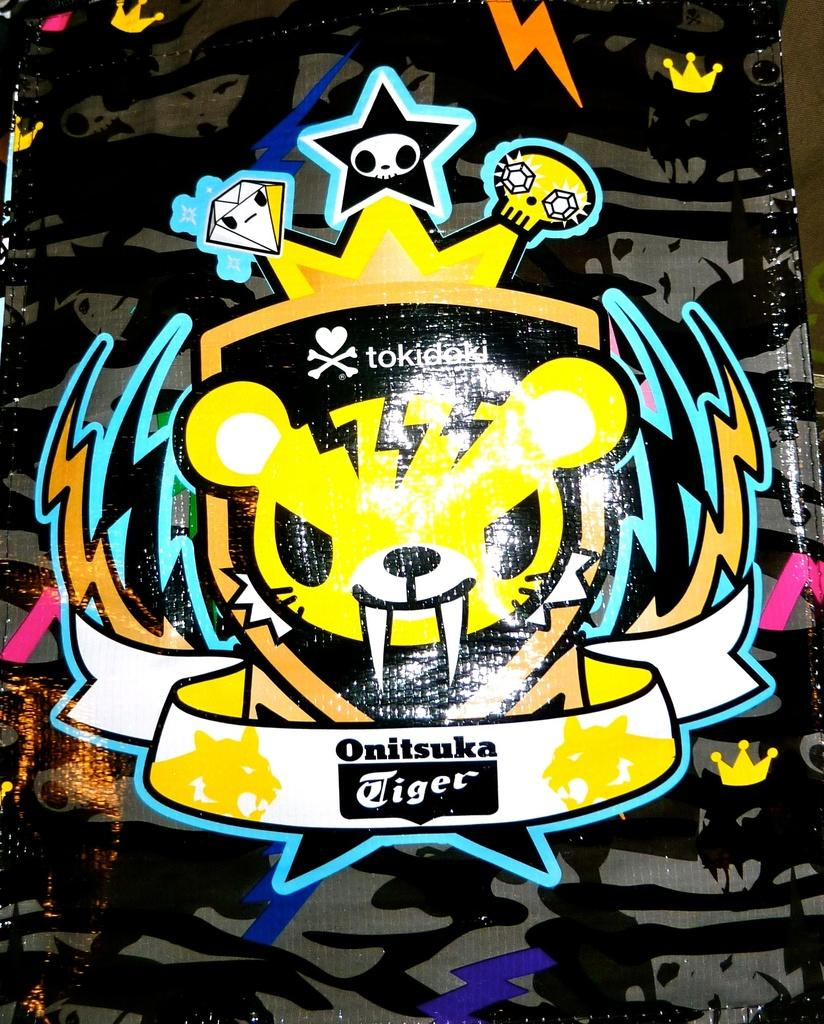What is the main subject of the image? The main subject of the image is a logo cover. Can you describe the location of the logo cover in the image? The logo cover is in the middle of the image. What is the name of the person holding the meat in the image? There is no person holding meat in the image, as the main subject is a logo cover. 